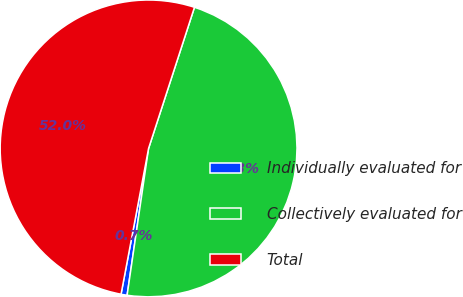Convert chart. <chart><loc_0><loc_0><loc_500><loc_500><pie_chart><fcel>Individually evaluated for<fcel>Collectively evaluated for<fcel>Total<nl><fcel>0.66%<fcel>47.31%<fcel>52.04%<nl></chart> 